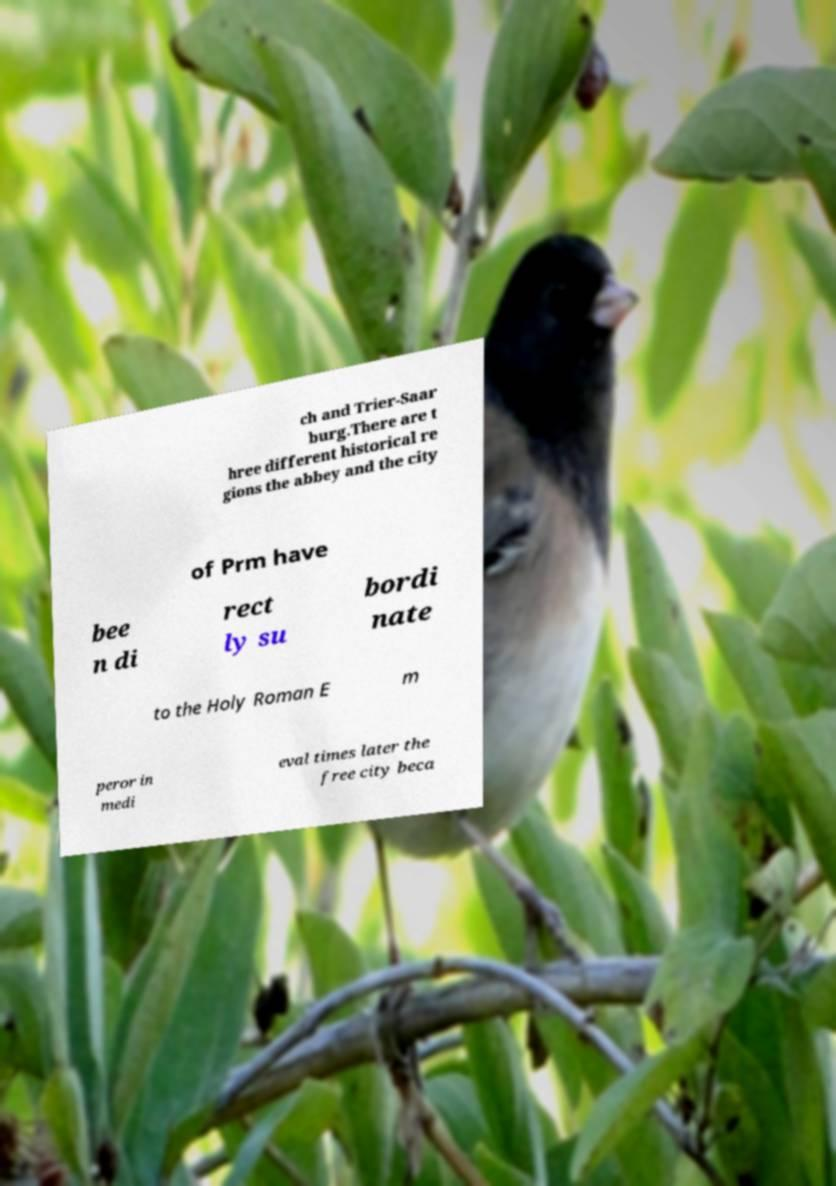Could you assist in decoding the text presented in this image and type it out clearly? ch and Trier-Saar burg.There are t hree different historical re gions the abbey and the city of Prm have bee n di rect ly su bordi nate to the Holy Roman E m peror in medi eval times later the free city beca 